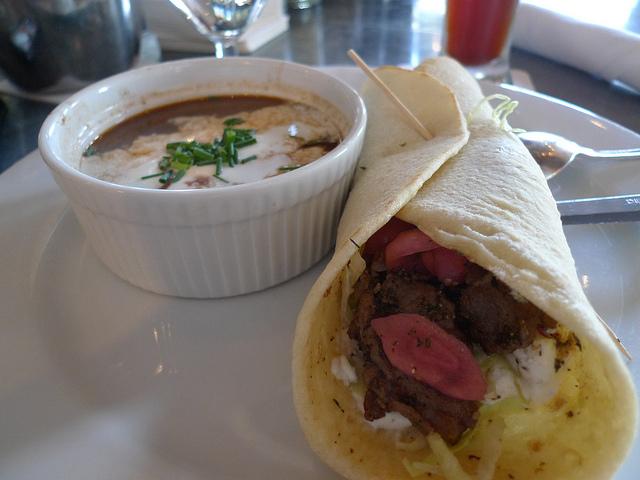What food item is on the plate?
Keep it brief. Burrito. Is the sandwich cut in half?
Be succinct. No. What color is the bowl?
Write a very short answer. White. What is the name of the restaurant?
Write a very short answer. Joe's diner. What is the sandwich wrapped in?
Be succinct. Tortilla. 